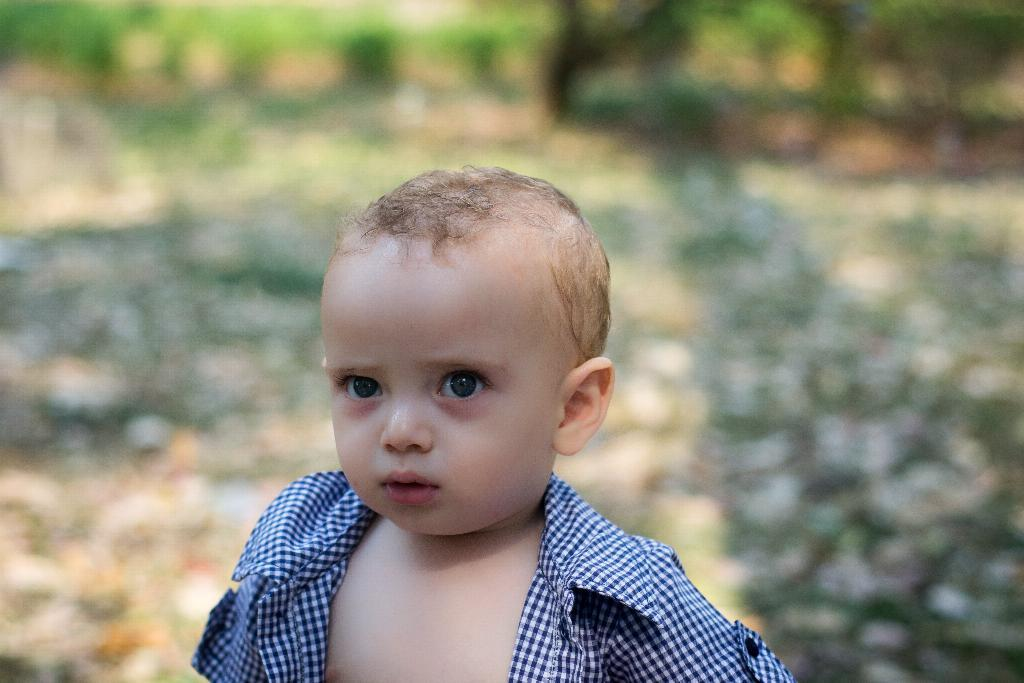Who is the main subject in the image? There is a small boy in the image. Where is the small boy located in the image? The small boy is in the center of the image. What can be observed about the background of the image? The background of the image is blurry. What type of jam is the small boy spreading on the bread in the image? There is no bread or jam present in the image; it only features a small boy in the center with a blurry background. 